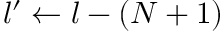<formula> <loc_0><loc_0><loc_500><loc_500>l ^ { \prime } \gets l - ( N + 1 )</formula> 